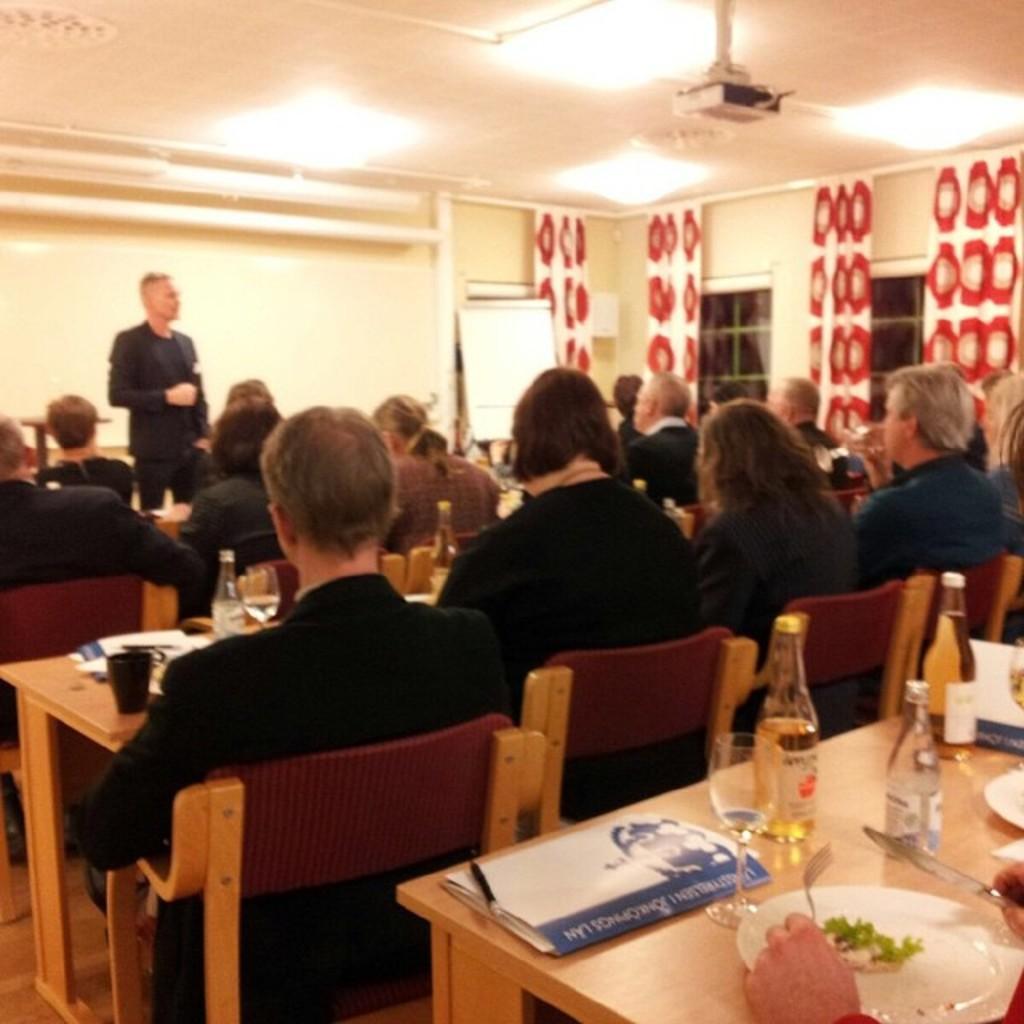Please provide a concise description of this image. Here we can see a group of people sitting on chairs and tables in front of them having bottles and glasses and plates and in the center there is a man standing and at the top right there is a projector 